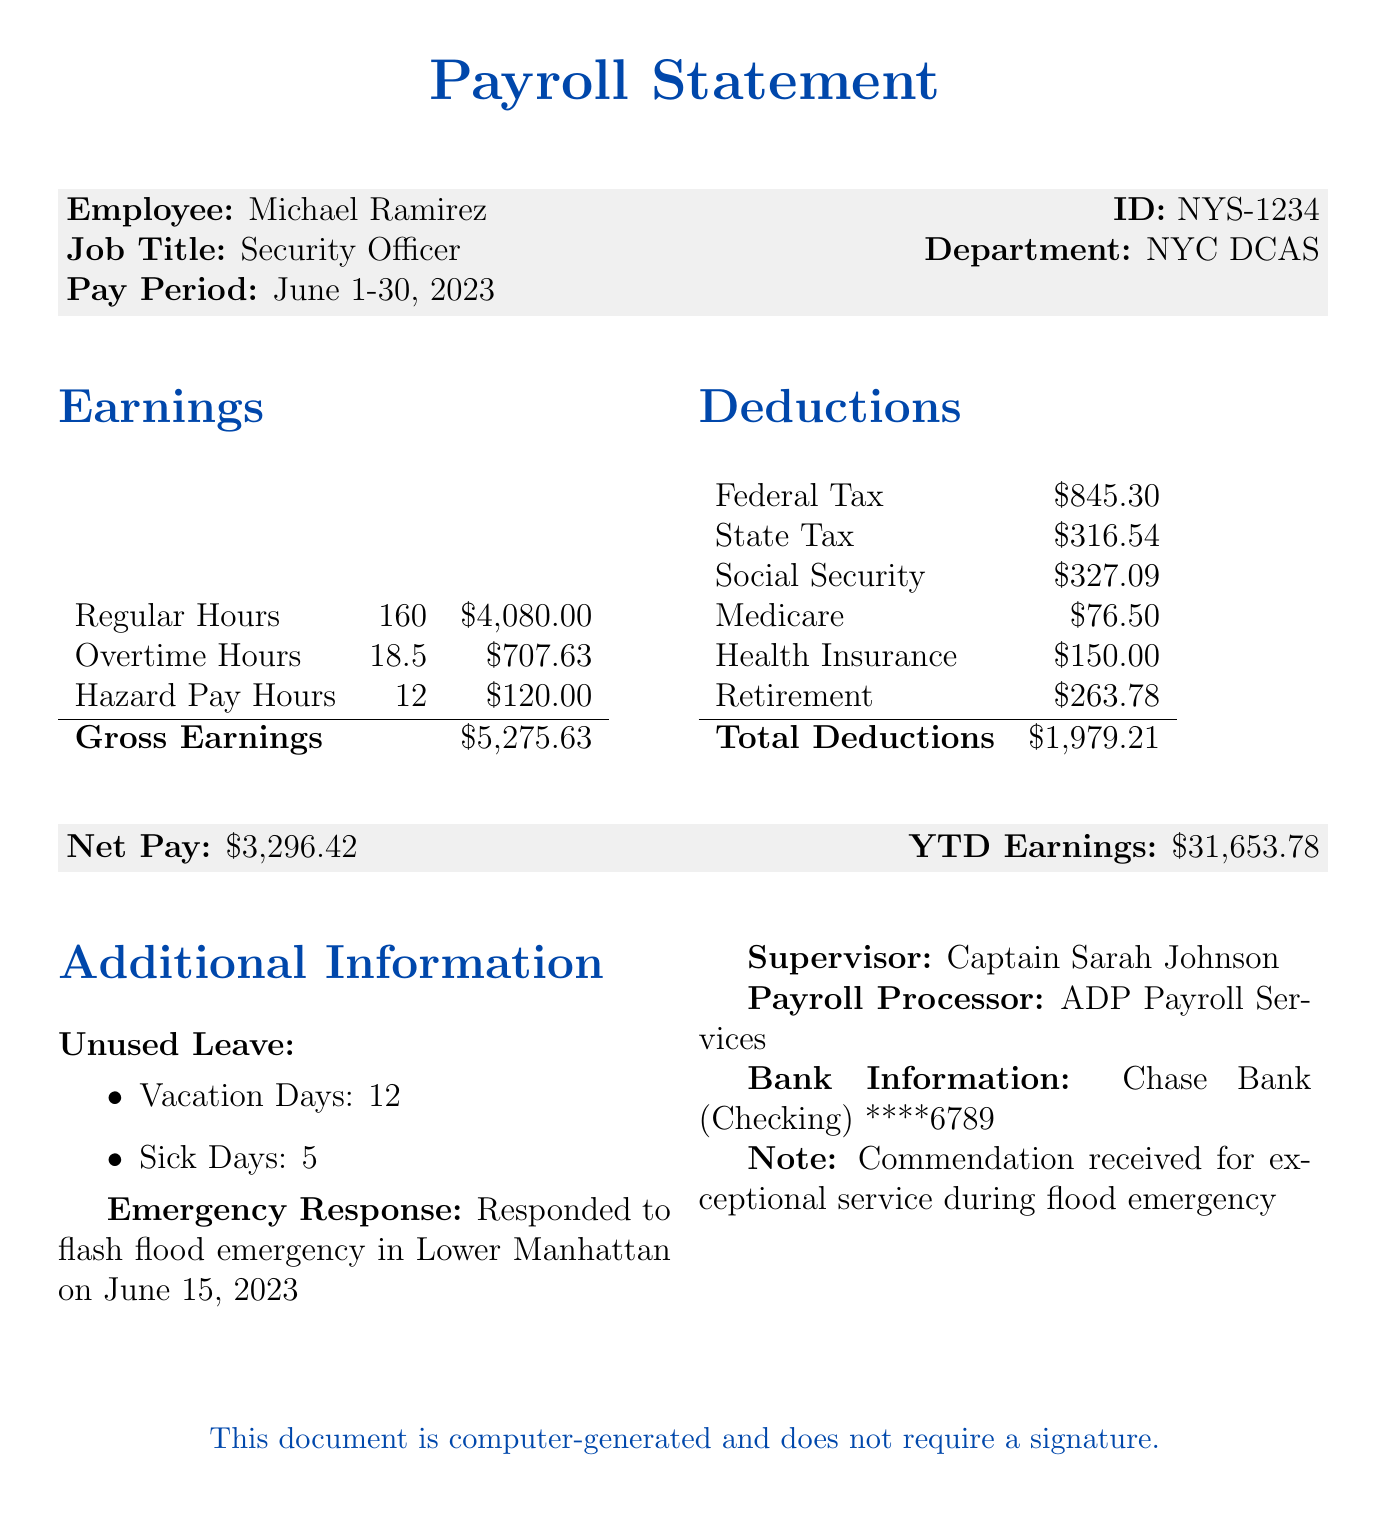What is the employee's name? The employee's name is stated clearly in the document as Michael Ramirez.
Answer: Michael Ramirez What were the regular hours worked? The document specifies that the regular hours worked were 160 hours.
Answer: 160 How much hazard pay did Michael receive? The hazard pay earned is indicated in the earnings section, amounting to $120.00 for the hours worked.
Answer: $120.00 What was the net pay for June 2023? The net pay is presented in the document as $3,296.42 after deductions.
Answer: $3,296.42 What emergency situation did Michael respond to? The document describes the emergency situation as a flash flood emergency in Lower Manhattan on June 15, 2023.
Answer: Flash flood emergency in Lower Manhattan on June 15, 2023 What is the total amount deducted from Michael's earnings? The total deductions add up to $1,979.21 which includes all types of deductions listed.
Answer: $1,979.21 Who is Michael's supervisor? The document lists Captain Sarah Johnson as Michael's supervisor.
Answer: Captain Sarah Johnson How many unused vacation days does Michael have? The document states that Michael has 12 unused vacation days.
Answer: 12 What was the payroll processor for this statement? According to the document, the payroll processor is ADP Payroll Services.
Answer: ADP Payroll Services 